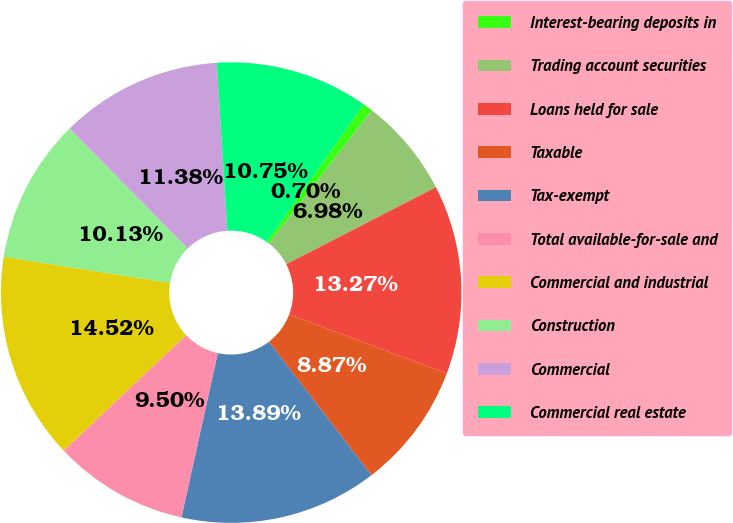<chart> <loc_0><loc_0><loc_500><loc_500><pie_chart><fcel>Interest-bearing deposits in<fcel>Trading account securities<fcel>Loans held for sale<fcel>Taxable<fcel>Tax-exempt<fcel>Total available-for-sale and<fcel>Commercial and industrial<fcel>Construction<fcel>Commercial<fcel>Commercial real estate<nl><fcel>0.7%<fcel>6.98%<fcel>13.27%<fcel>8.87%<fcel>13.89%<fcel>9.5%<fcel>14.52%<fcel>10.13%<fcel>11.38%<fcel>10.75%<nl></chart> 